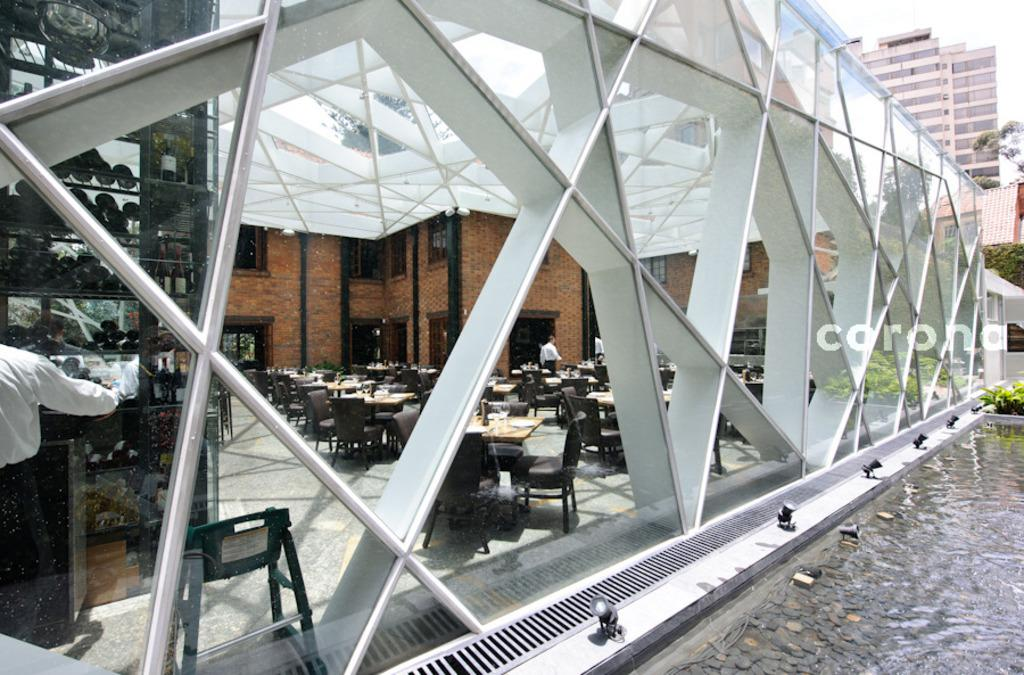What type of establishment is shown in the image? The image depicts a restaurant. What furniture is present in the restaurant? There are chairs and tables in the restaurant. Can you describe the person in the image? A human is standing far away in the image. What can be seen in the distance from the restaurant? There is a building visible in the distance. What natural elements are present in the background? Trees are present in the background. What is the body of water in the image like? There is a body of water with stones in the image. How many cats are sitting on the straw in the image? There are no cats or straw present in the image. What type of men can be seen in the image? There is only one human visible in the image, and their gender cannot be determined from the image. 